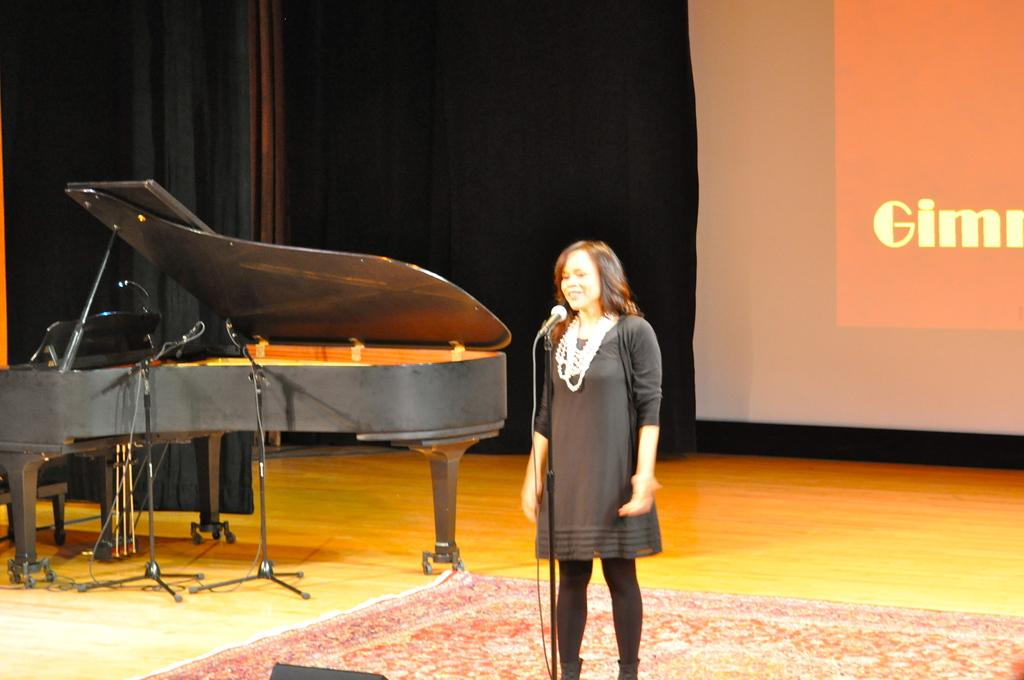What is the main subject of the image? There is a person standing in the image. What object is present near the person? There is a microphone with a stand in the image. What activity might the person be engaged in? The presence of a musical instrument suggests that the person might be performing or practicing music. What can be seen in the background of the image? There is a screen visible in the background of the image. What is the surface on which the person is standing? There is a floor in the image. What type of plants can be seen growing on the person's fingers in the image? There are no plants visible on the person's fingers in the image. How does the comb help the person perform in the image? There is no comb present in the image, so it cannot help the person perform. 